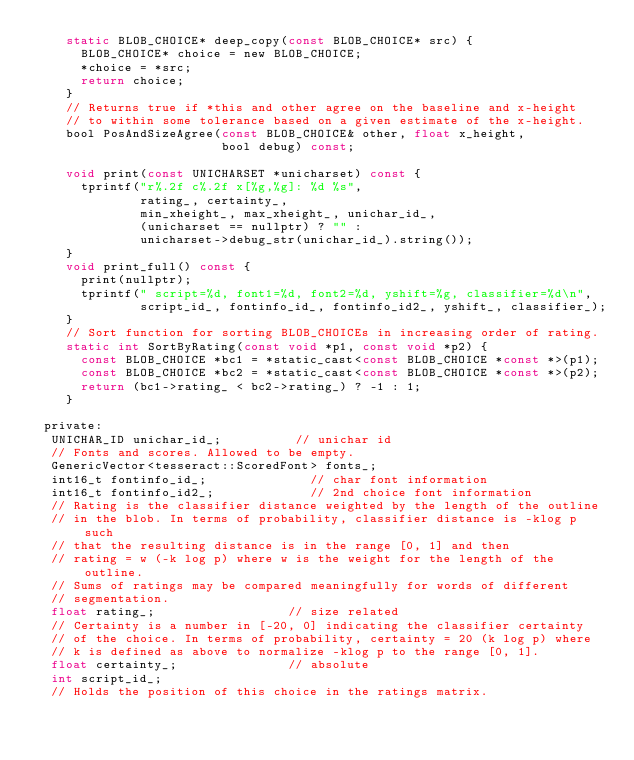Convert code to text. <code><loc_0><loc_0><loc_500><loc_500><_C_>    static BLOB_CHOICE* deep_copy(const BLOB_CHOICE* src) {
      BLOB_CHOICE* choice = new BLOB_CHOICE;
      *choice = *src;
      return choice;
    }
    // Returns true if *this and other agree on the baseline and x-height
    // to within some tolerance based on a given estimate of the x-height.
    bool PosAndSizeAgree(const BLOB_CHOICE& other, float x_height,
                         bool debug) const;

    void print(const UNICHARSET *unicharset) const {
      tprintf("r%.2f c%.2f x[%g,%g]: %d %s",
              rating_, certainty_,
              min_xheight_, max_xheight_, unichar_id_,
              (unicharset == nullptr) ? "" :
              unicharset->debug_str(unichar_id_).string());
    }
    void print_full() const {
      print(nullptr);
      tprintf(" script=%d, font1=%d, font2=%d, yshift=%g, classifier=%d\n",
              script_id_, fontinfo_id_, fontinfo_id2_, yshift_, classifier_);
    }
    // Sort function for sorting BLOB_CHOICEs in increasing order of rating.
    static int SortByRating(const void *p1, const void *p2) {
      const BLOB_CHOICE *bc1 = *static_cast<const BLOB_CHOICE *const *>(p1);
      const BLOB_CHOICE *bc2 = *static_cast<const BLOB_CHOICE *const *>(p2);
      return (bc1->rating_ < bc2->rating_) ? -1 : 1;
    }

 private:
  UNICHAR_ID unichar_id_;          // unichar id
  // Fonts and scores. Allowed to be empty.
  GenericVector<tesseract::ScoredFont> fonts_;
  int16_t fontinfo_id_;              // char font information
  int16_t fontinfo_id2_;             // 2nd choice font information
  // Rating is the classifier distance weighted by the length of the outline
  // in the blob. In terms of probability, classifier distance is -klog p such
  // that the resulting distance is in the range [0, 1] and then
  // rating = w (-k log p) where w is the weight for the length of the outline.
  // Sums of ratings may be compared meaningfully for words of different
  // segmentation.
  float rating_;                  // size related
  // Certainty is a number in [-20, 0] indicating the classifier certainty
  // of the choice. In terms of probability, certainty = 20 (k log p) where
  // k is defined as above to normalize -klog p to the range [0, 1].
  float certainty_;               // absolute
  int script_id_;
  // Holds the position of this choice in the ratings matrix.</code> 